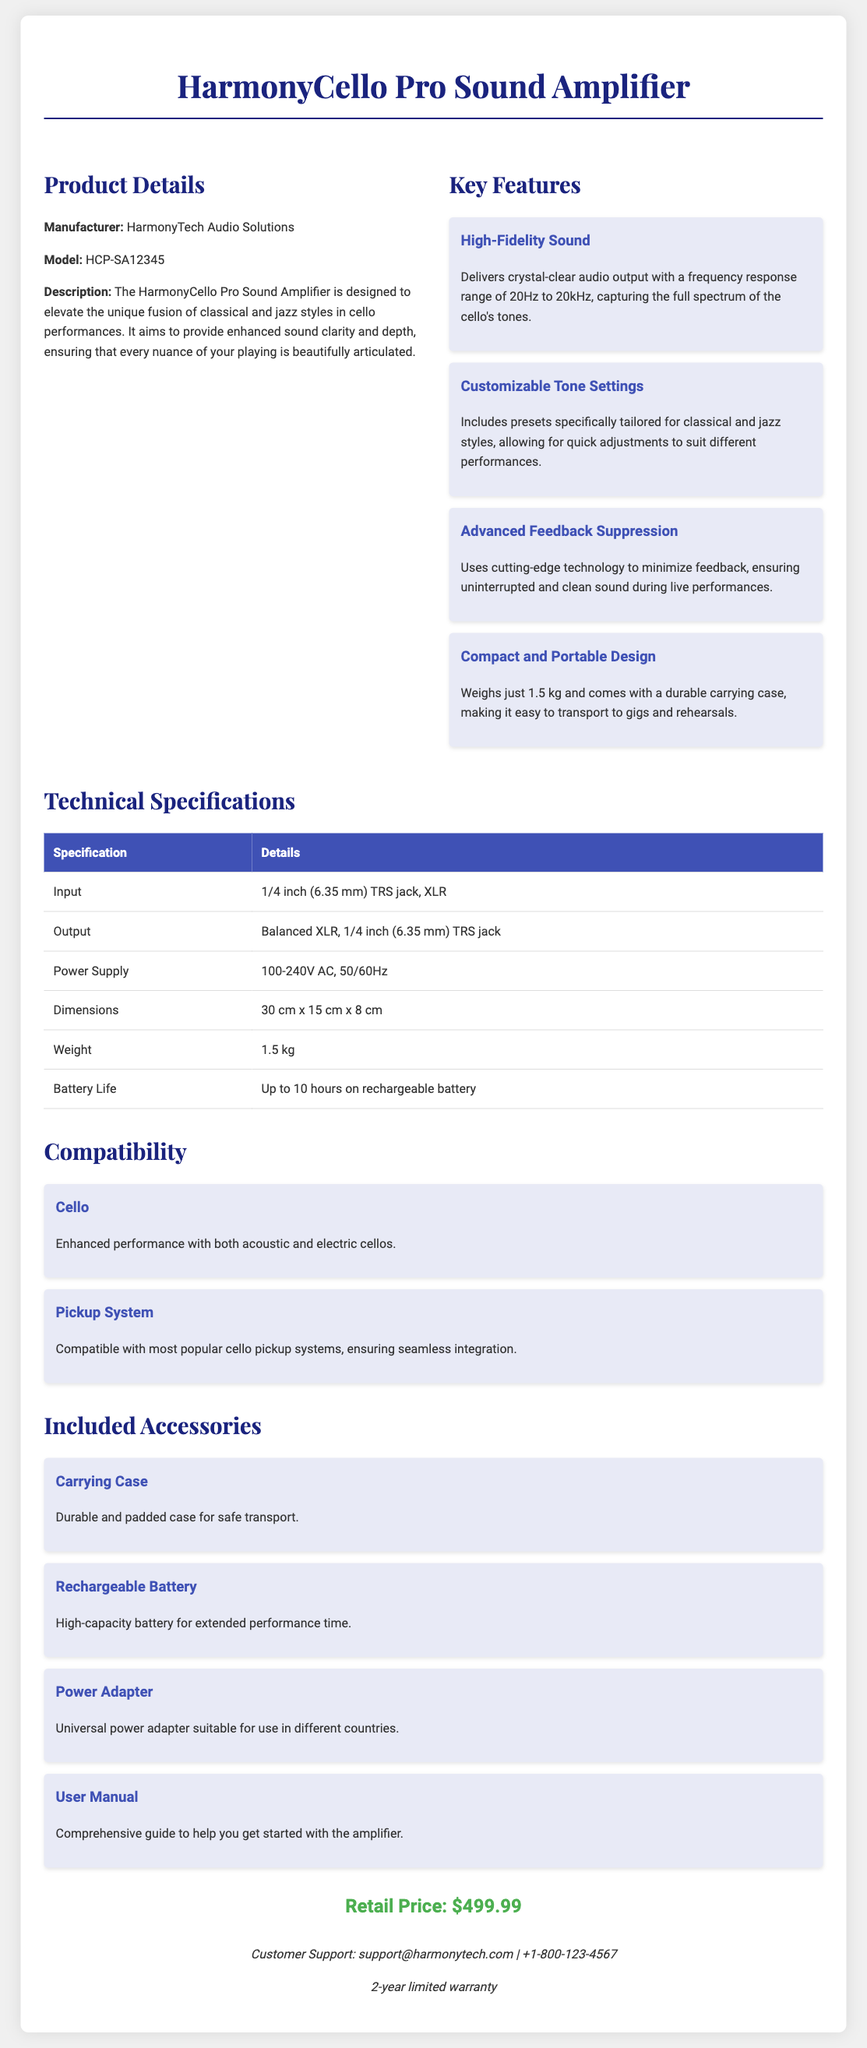What is the model of the amplifier? The model is indicated in the product details section of the document.
Answer: HCP-SA12345 What is the weight of the HarmonyCello Pro? The document specifies the weight in the technical specifications section.
Answer: 1.5 kg What type of audio output does the amplifier provide? The output specifications in the document detail the types of outputs available.
Answer: Balanced XLR, 1/4 inch (6.35 mm) TRS jack How many hours of battery life does it have? The battery life is specified under technical specifications in the document.
Answer: Up to 10 hours What is included with the amplifier? The included accessories section lists the items that come with the product.
Answer: Carrying Case, Rechargeable Battery, Power Adapter, User Manual What technology minimizes feedback in this amplifier? The features section mentions a specific technology used for feedback suppression.
Answer: Advanced Feedback Suppression What is the retail price of the amplifier? The retail price is stated clearly near the end of the document.
Answer: $499.99 Which music styles are the tone settings customized for? The key features describe customization for specific music styles.
Answer: Classical and jazz Who is the manufacturer of the amplifier? The manufacturer is mentioned in the product details section of the document.
Answer: HarmonyTech Audio Solutions 